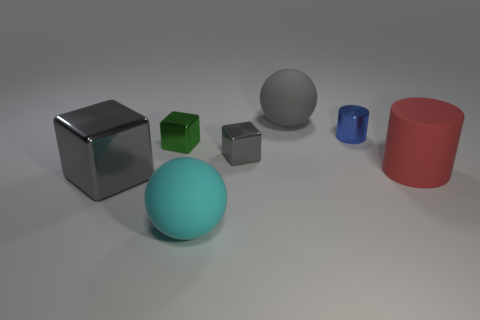Is there a small metallic cube that has the same color as the big metallic object?
Provide a succinct answer. Yes. There is a large sphere that is the same color as the large shiny thing; what is it made of?
Offer a very short reply. Rubber. How many small metal things are the same color as the big block?
Offer a very short reply. 1. Is there a matte ball of the same size as the cyan rubber thing?
Offer a very short reply. Yes. What number of objects are rubber cylinders that are behind the big cyan matte object or large rubber things in front of the big red matte object?
Make the answer very short. 2. What is the shape of the gray metallic object that is the same size as the blue metallic cylinder?
Offer a very short reply. Cube. Are there any other rubber objects that have the same shape as the blue object?
Your answer should be compact. Yes. Are there fewer small blue shiny cylinders than gray metallic blocks?
Your answer should be compact. Yes. Does the rubber object that is behind the red object have the same size as the gray metallic thing that is right of the cyan rubber ball?
Ensure brevity in your answer.  No. How many things are large yellow rubber objects or matte objects?
Ensure brevity in your answer.  3. 